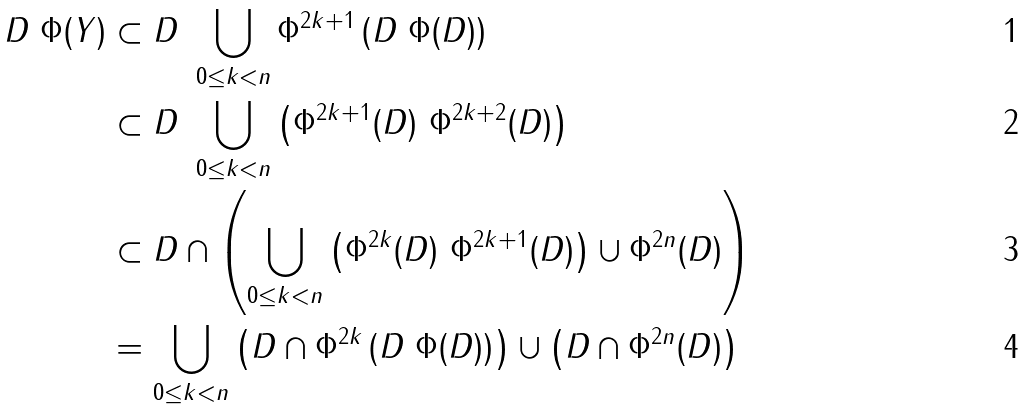<formula> <loc_0><loc_0><loc_500><loc_500>D \ \Phi ( Y ) & \subset D \ \bigcup _ { 0 \leq k < n } \Phi ^ { 2 k + 1 } \left ( D \ \Phi ( D ) \right ) \\ & \subset D \ \bigcup _ { 0 \leq k < n } \left ( \Phi ^ { 2 k + 1 } ( D ) \ \Phi ^ { 2 k + 2 } ( D ) \right ) \\ & \subset D \cap \left ( \bigcup _ { 0 \leq k < n } \left ( \Phi ^ { 2 k } ( D ) \ \Phi ^ { 2 k + 1 } ( D ) \right ) \cup \Phi ^ { 2 n } ( D ) \right ) \\ & = \bigcup _ { 0 \leq k < n } \left ( D \cap \Phi ^ { 2 k } \left ( D \ \Phi ( D ) \right ) \right ) \cup \left ( D \cap \Phi ^ { 2 n } ( D ) \right )</formula> 